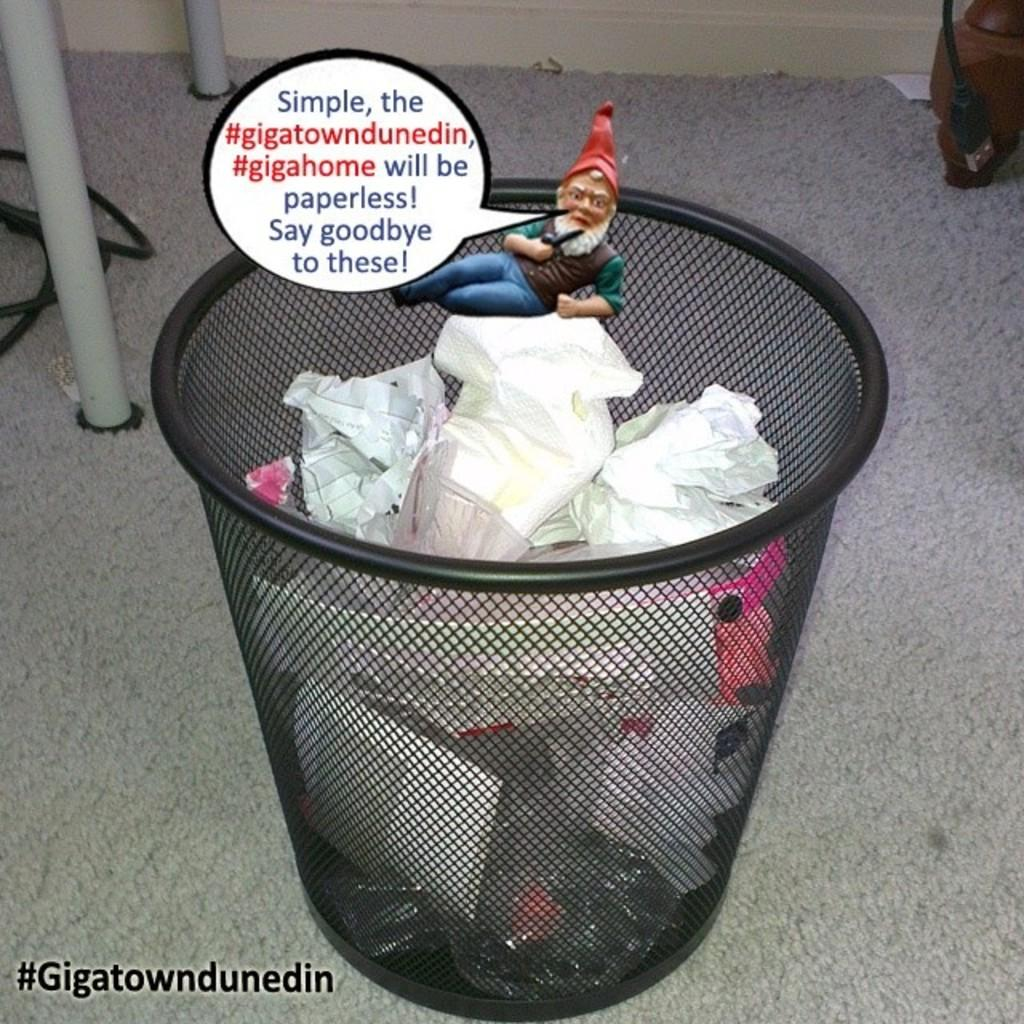Provide a one-sentence caption for the provided image. A message from the #Gigatowndunedin states that they will become paperless and will not need a garbage can. 